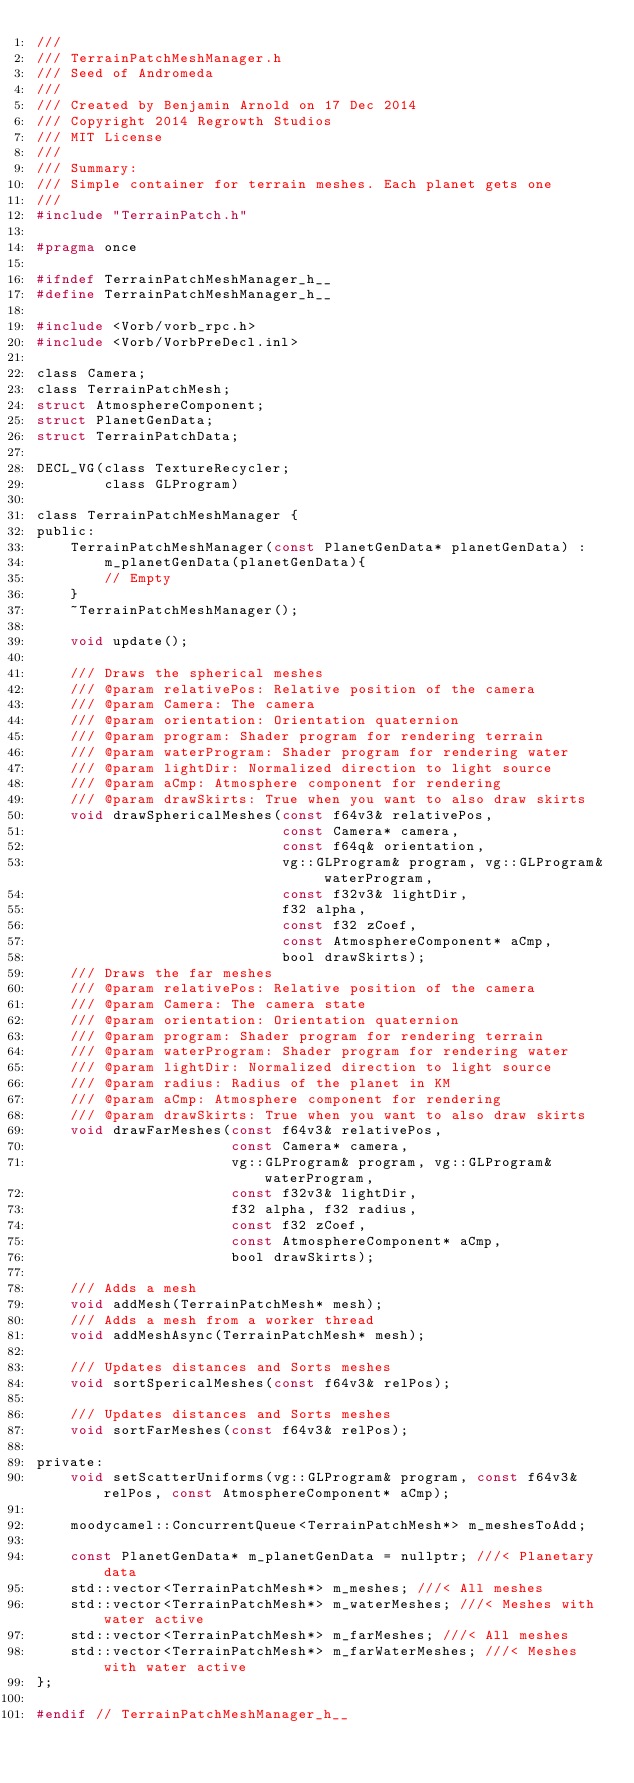<code> <loc_0><loc_0><loc_500><loc_500><_C_>///
/// TerrainPatchMeshManager.h
/// Seed of Andromeda
///
/// Created by Benjamin Arnold on 17 Dec 2014
/// Copyright 2014 Regrowth Studios
/// MIT License
///
/// Summary:
/// Simple container for terrain meshes. Each planet gets one
///
#include "TerrainPatch.h"

#pragma once

#ifndef TerrainPatchMeshManager_h__
#define TerrainPatchMeshManager_h__

#include <Vorb/vorb_rpc.h>
#include <Vorb/VorbPreDecl.inl>

class Camera;
class TerrainPatchMesh;
struct AtmosphereComponent;
struct PlanetGenData;
struct TerrainPatchData;

DECL_VG(class TextureRecycler;
        class GLProgram)

class TerrainPatchMeshManager {
public:
    TerrainPatchMeshManager(const PlanetGenData* planetGenData) :
        m_planetGenData(planetGenData){
        // Empty
    }
    ~TerrainPatchMeshManager();

    void update();

    /// Draws the spherical meshes
    /// @param relativePos: Relative position of the camera
    /// @param Camera: The camera
    /// @param orientation: Orientation quaternion
    /// @param program: Shader program for rendering terrain
    /// @param waterProgram: Shader program for rendering water
    /// @param lightDir: Normalized direction to light source
    /// @param aCmp: Atmosphere component for rendering
    /// @param drawSkirts: True when you want to also draw skirts
    void drawSphericalMeshes(const f64v3& relativePos,
                             const Camera* camera,
                             const f64q& orientation,
                             vg::GLProgram& program, vg::GLProgram& waterProgram,
                             const f32v3& lightDir,
                             f32 alpha,
                             const f32 zCoef,
                             const AtmosphereComponent* aCmp,
                             bool drawSkirts);
    /// Draws the far meshes
    /// @param relativePos: Relative position of the camera
    /// @param Camera: The camera state
    /// @param orientation: Orientation quaternion
    /// @param program: Shader program for rendering terrain
    /// @param waterProgram: Shader program for rendering water
    /// @param lightDir: Normalized direction to light source
    /// @param radius: Radius of the planet in KM
    /// @param aCmp: Atmosphere component for rendering
    /// @param drawSkirts: True when you want to also draw skirts
    void drawFarMeshes(const f64v3& relativePos,
                       const Camera* camera,
                       vg::GLProgram& program, vg::GLProgram& waterProgram,
                       const f32v3& lightDir,
                       f32 alpha, f32 radius,
                       const f32 zCoef,
                       const AtmosphereComponent* aCmp,
                       bool drawSkirts);

    /// Adds a mesh 
    void addMesh(TerrainPatchMesh* mesh);
    /// Adds a mesh from a worker thread
    void addMeshAsync(TerrainPatchMesh* mesh);

    /// Updates distances and Sorts meshes
    void sortSpericalMeshes(const f64v3& relPos);

    /// Updates distances and Sorts meshes
    void sortFarMeshes(const f64v3& relPos);

private:
    void setScatterUniforms(vg::GLProgram& program, const f64v3& relPos, const AtmosphereComponent* aCmp);

    moodycamel::ConcurrentQueue<TerrainPatchMesh*> m_meshesToAdd;

    const PlanetGenData* m_planetGenData = nullptr; ///< Planetary data
    std::vector<TerrainPatchMesh*> m_meshes; ///< All meshes
    std::vector<TerrainPatchMesh*> m_waterMeshes; ///< Meshes with water active
    std::vector<TerrainPatchMesh*> m_farMeshes; ///< All meshes
    std::vector<TerrainPatchMesh*> m_farWaterMeshes; ///< Meshes with water active
};

#endif // TerrainPatchMeshManager_h__
</code> 